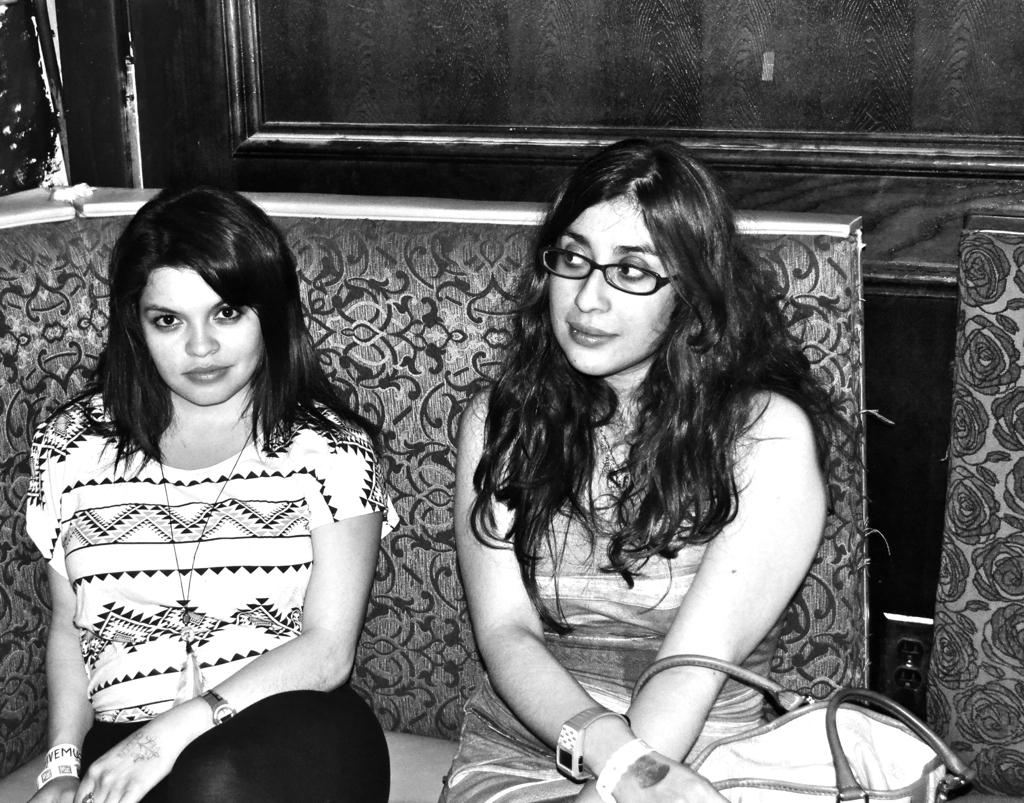How many people are in the image? There are two women in the image. What are the women doing in the image? The women are sitting on a sofa. Can you describe the background of the image? There are objects visible in the background of the image. What type of pail is being used for transport in the image? There is no pail or transportation activity present in the image. What causes a spark between the two women in the image? There is no spark or any indication of a spark between the two women in the image. 